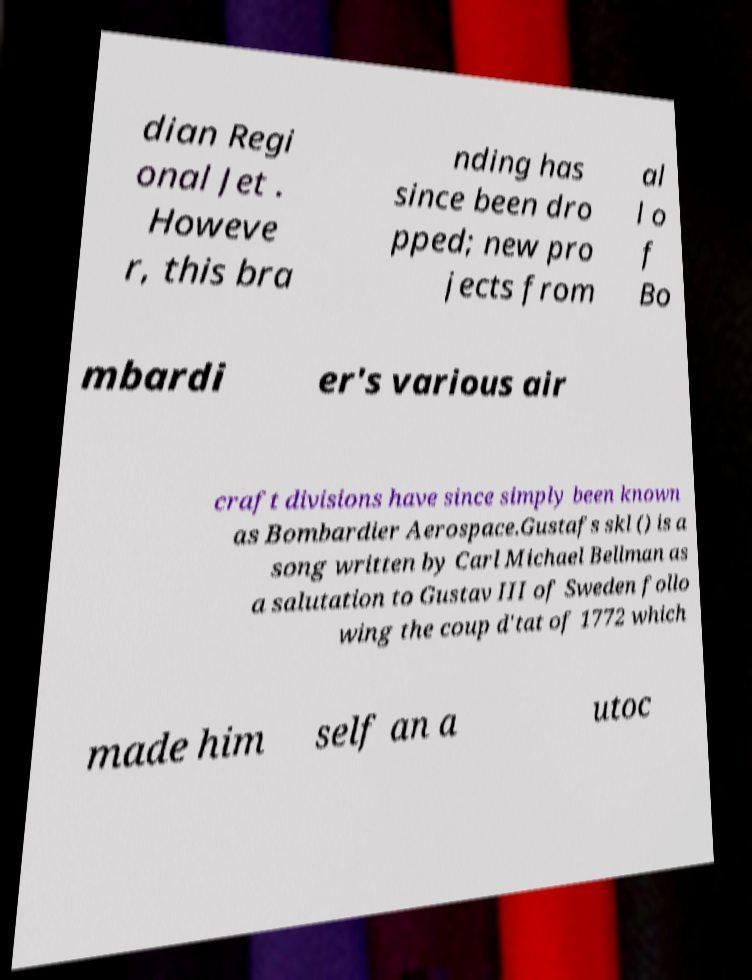For documentation purposes, I need the text within this image transcribed. Could you provide that? dian Regi onal Jet . Howeve r, this bra nding has since been dro pped; new pro jects from al l o f Bo mbardi er's various air craft divisions have since simply been known as Bombardier Aerospace.Gustafs skl () is a song written by Carl Michael Bellman as a salutation to Gustav III of Sweden follo wing the coup d'tat of 1772 which made him self an a utoc 